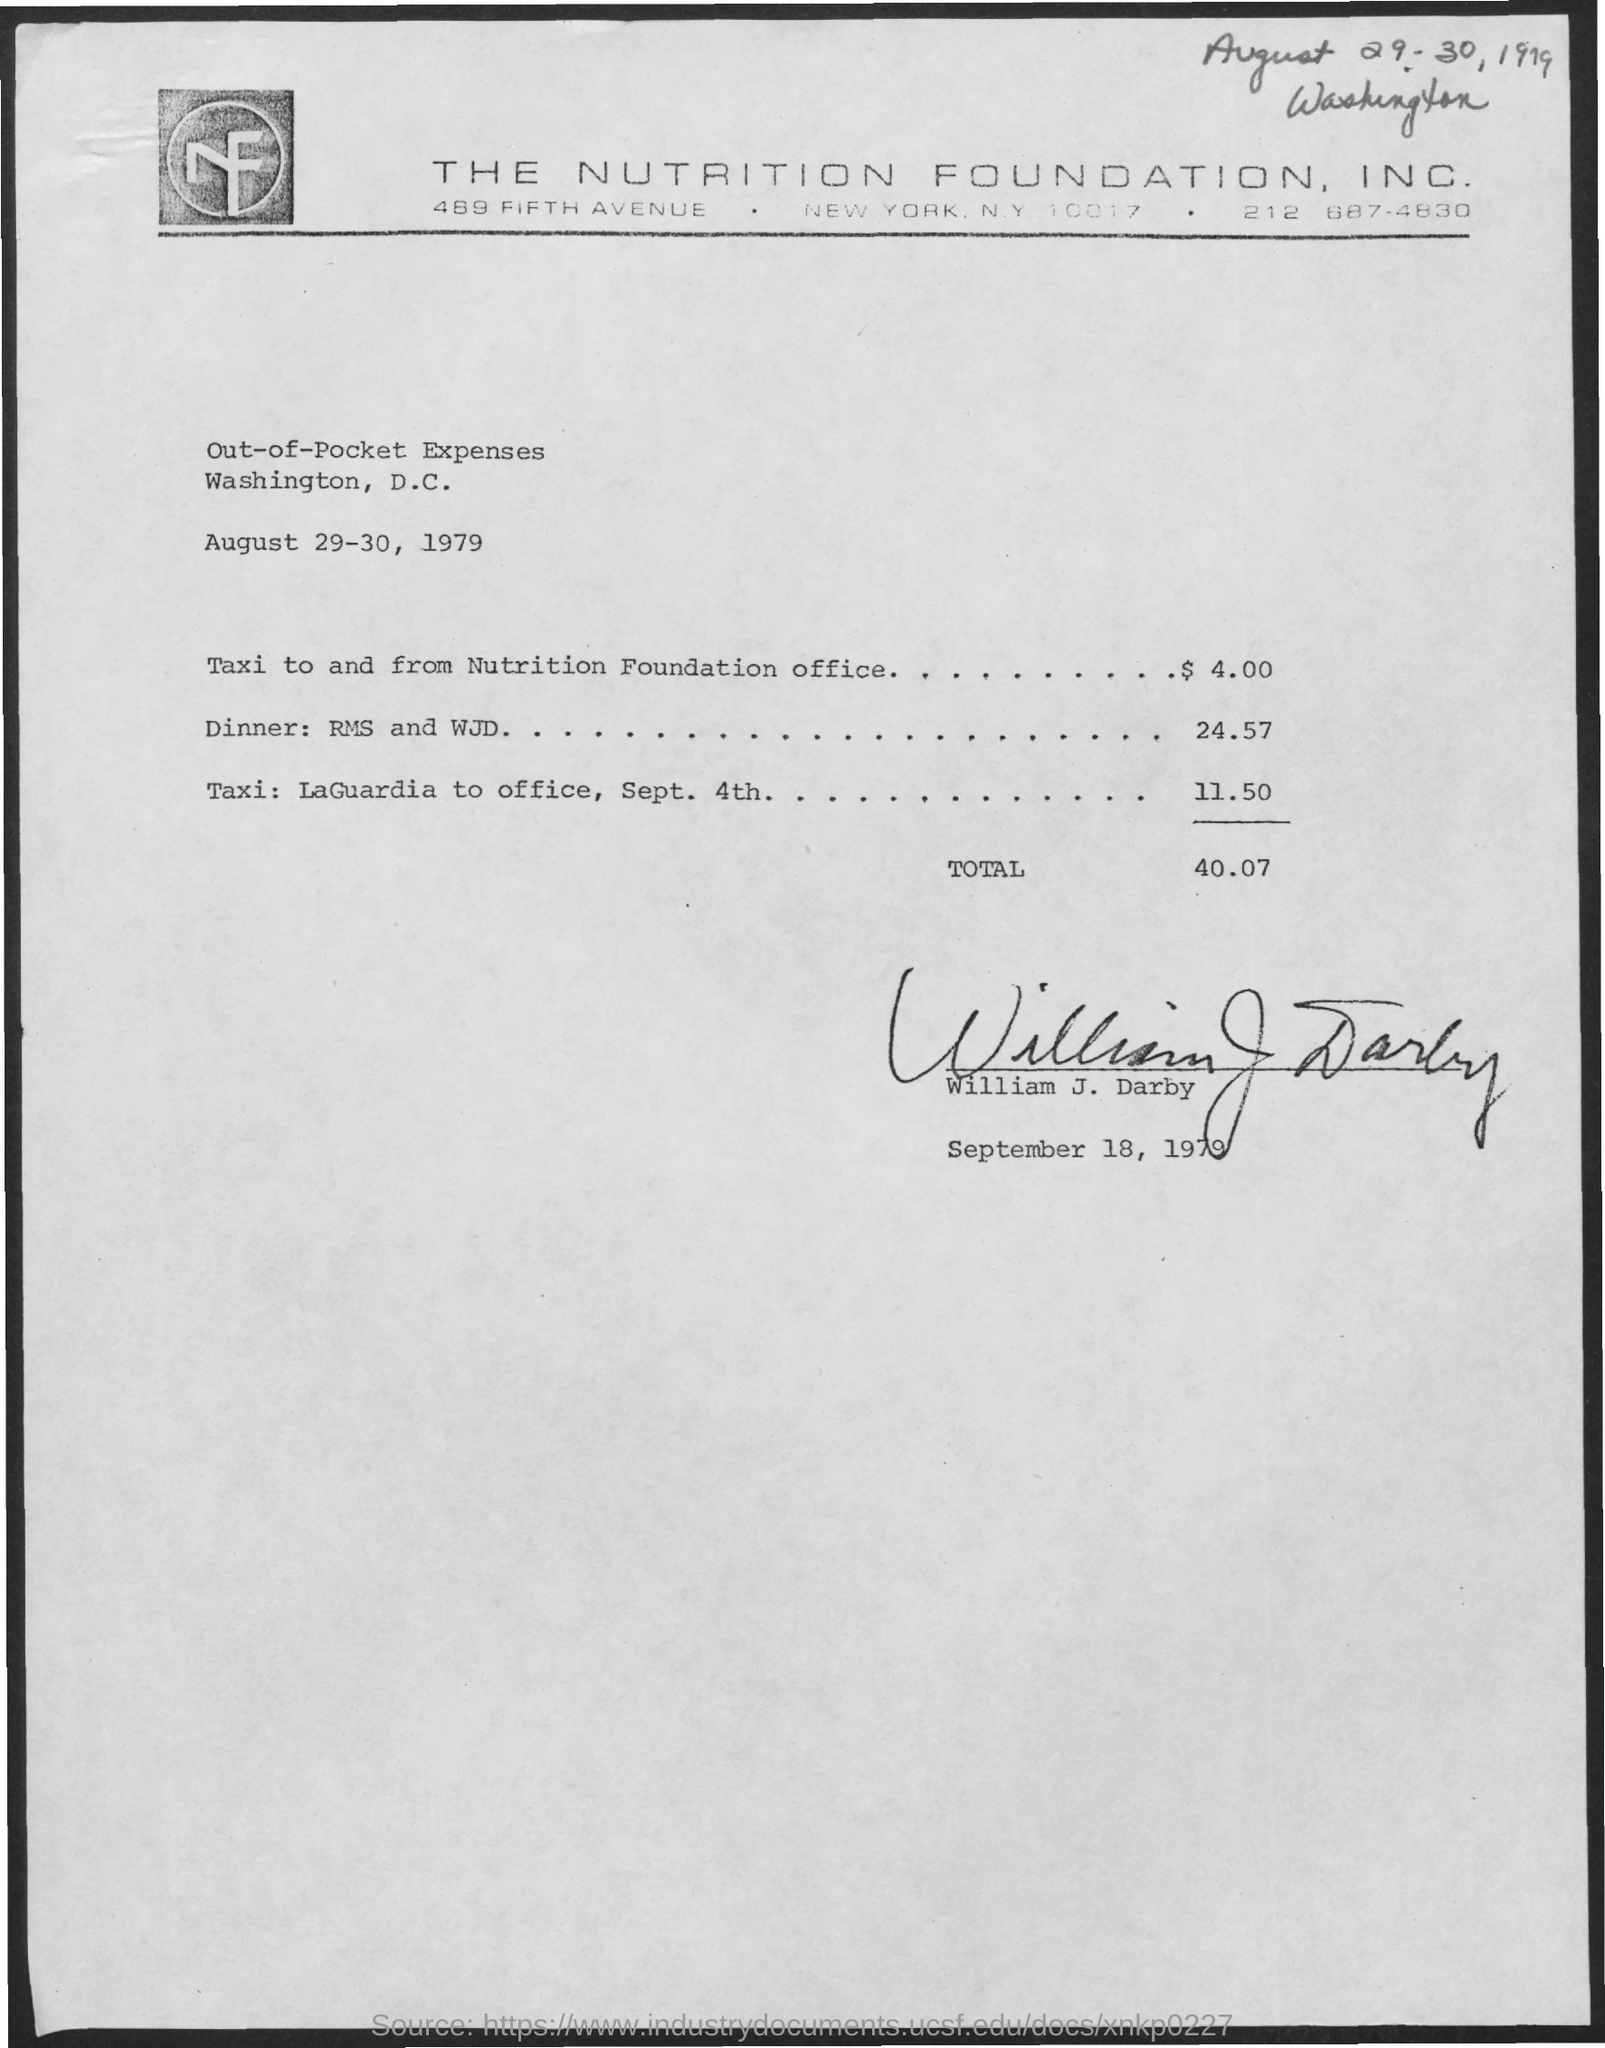List a handful of essential elements in this visual. The Nutrition Foundation, Inc. is the company mentioned in the header of the document. 